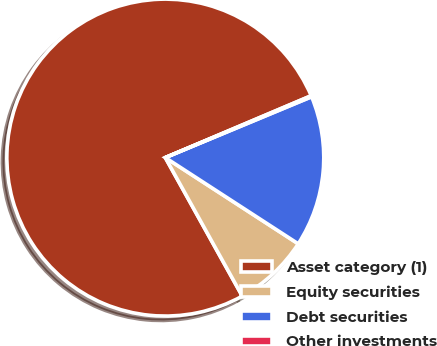Convert chart. <chart><loc_0><loc_0><loc_500><loc_500><pie_chart><fcel>Asset category (1)<fcel>Equity securities<fcel>Debt securities<fcel>Other investments<nl><fcel>76.69%<fcel>7.77%<fcel>15.43%<fcel>0.11%<nl></chart> 